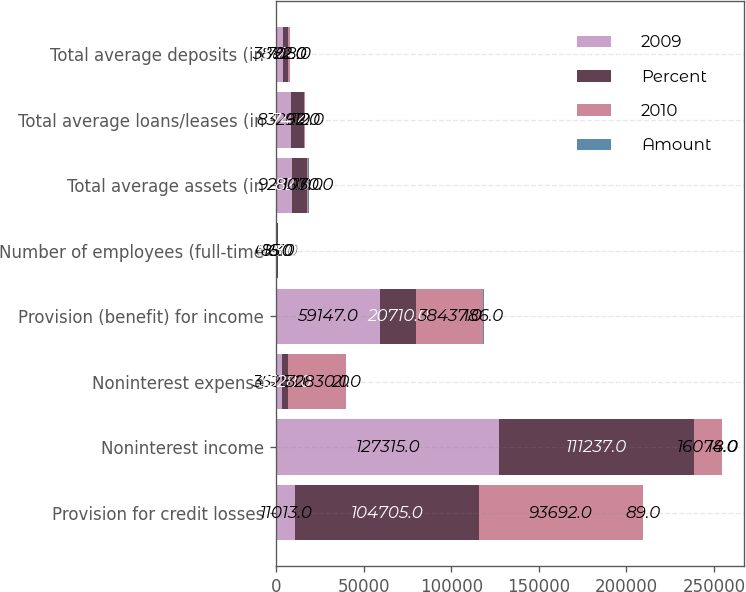Convert chart. <chart><loc_0><loc_0><loc_500><loc_500><stacked_bar_chart><ecel><fcel>Provision for credit losses<fcel>Noninterest income<fcel>Noninterest expense<fcel>Provision (benefit) for income<fcel>Number of employees (full-time<fcel>Total average assets (in<fcel>Total average loans/leases (in<fcel>Total average deposits (in<nl><fcel>2009<fcel>11013<fcel>127315<fcel>3528<fcel>59147<fcel>623<fcel>9283<fcel>8326<fcel>3882<nl><fcel>Percent<fcel>104705<fcel>111237<fcel>3528<fcel>20710<fcel>538<fcel>8213<fcel>7414<fcel>3174<nl><fcel>2010<fcel>93692<fcel>16078<fcel>32830<fcel>38437<fcel>85<fcel>1070<fcel>912<fcel>708<nl><fcel>Amount<fcel>89<fcel>14<fcel>21<fcel>186<fcel>16<fcel>13<fcel>12<fcel>22<nl></chart> 